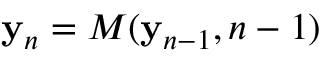Convert formula to latex. <formula><loc_0><loc_0><loc_500><loc_500>{ y } _ { n } = M ( { y } _ { n - 1 } , n - 1 )</formula> 